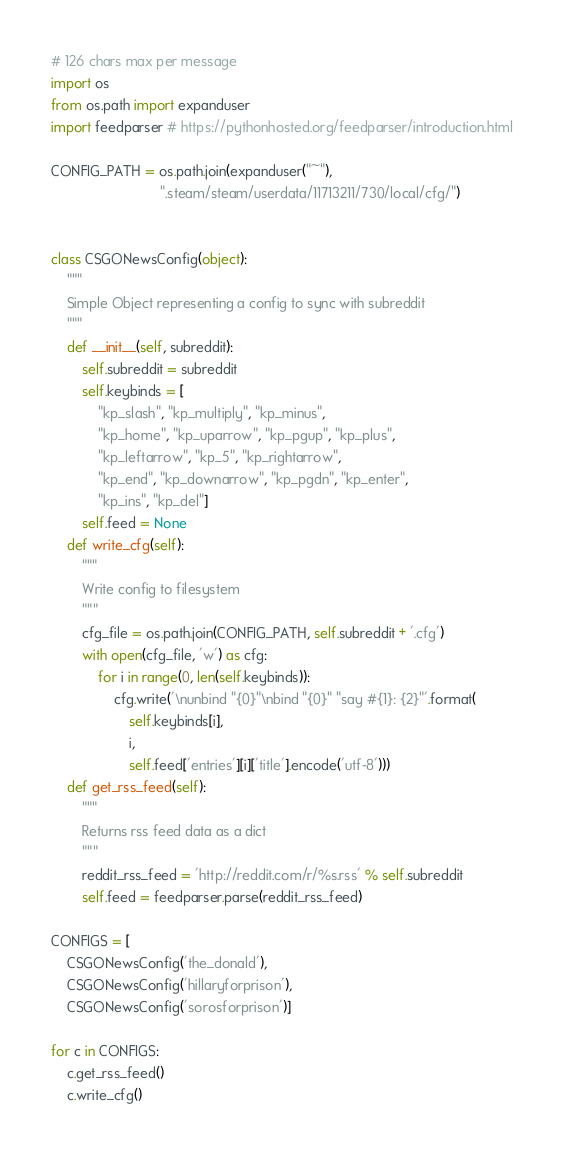<code> <loc_0><loc_0><loc_500><loc_500><_Python_># 126 chars max per message
import os
from os.path import expanduser
import feedparser # https://pythonhosted.org/feedparser/introduction.html

CONFIG_PATH = os.path.join(expanduser("~"),
                            ".steam/steam/userdata/11713211/730/local/cfg/")


class CSGONewsConfig(object):
    """
    Simple Object representing a config to sync with subreddit
    """
    def __init__(self, subreddit):
        self.subreddit = subreddit
        self.keybinds = [
            "kp_slash", "kp_multiply", "kp_minus",
            "kp_home", "kp_uparrow", "kp_pgup", "kp_plus",
            "kp_leftarrow", "kp_5", "kp_rightarrow",
            "kp_end", "kp_downarrow", "kp_pgdn", "kp_enter",
            "kp_ins", "kp_del"]
        self.feed = None
    def write_cfg(self):
        """
        Write config to filesystem
        """
        cfg_file = os.path.join(CONFIG_PATH, self.subreddit + '.cfg')
        with open(cfg_file, 'w') as cfg:
            for i in range(0, len(self.keybinds)):
                cfg.write('\nunbind "{0}"\nbind "{0}" "say #{1}: {2}"'.format(
                    self.keybinds[i],
                    i,
                    self.feed['entries'][i]['title'].encode('utf-8')))
    def get_rss_feed(self):
        """
        Returns rss feed data as a dict
        """
        reddit_rss_feed = 'http://reddit.com/r/%s.rss' % self.subreddit
        self.feed = feedparser.parse(reddit_rss_feed)

CONFIGS = [
    CSGONewsConfig('the_donald'),
    CSGONewsConfig('hillaryforprison'),
    CSGONewsConfig('sorosforprison')]

for c in CONFIGS:
    c.get_rss_feed()
    c.write_cfg()
</code> 